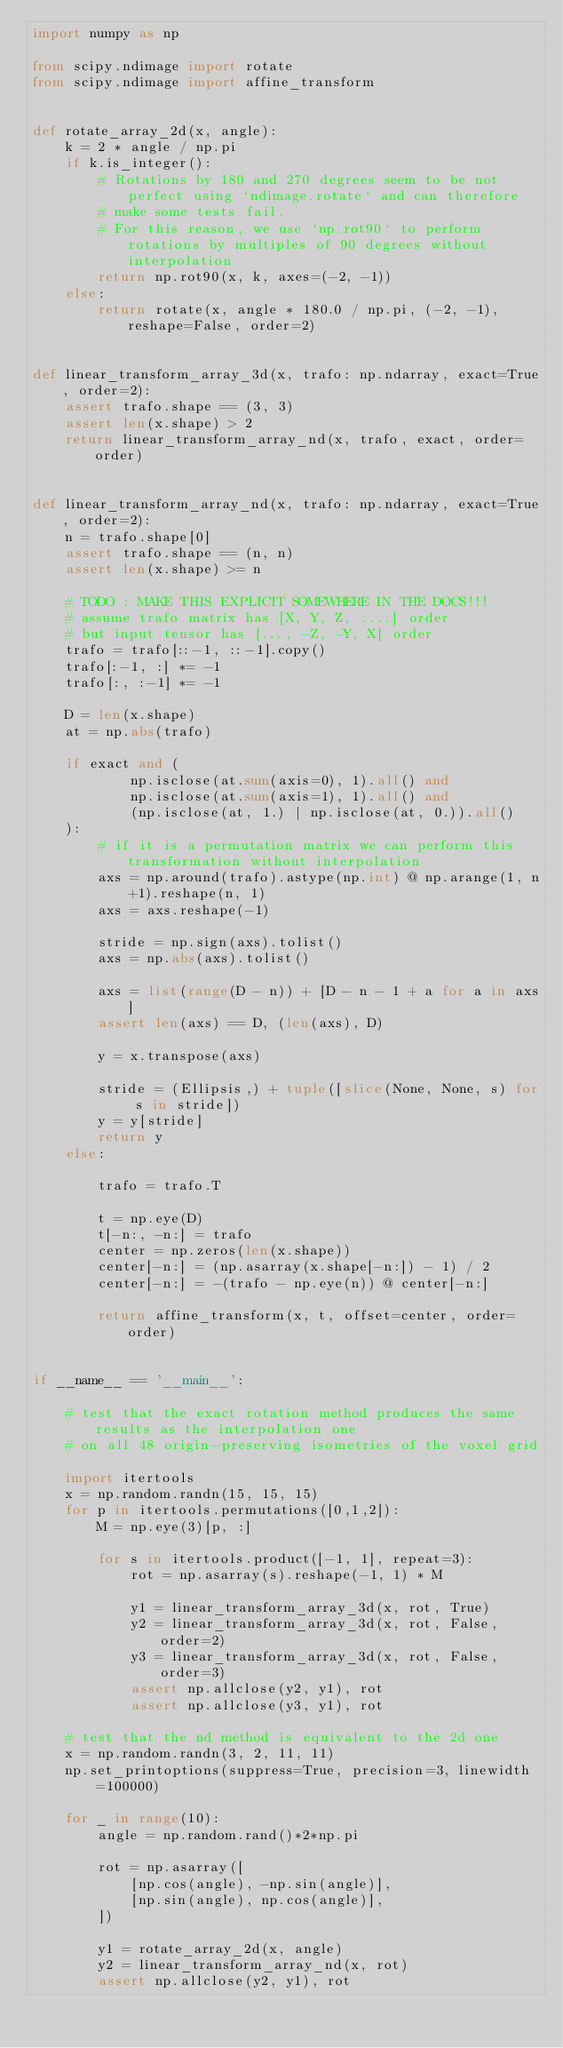<code> <loc_0><loc_0><loc_500><loc_500><_Python_>import numpy as np

from scipy.ndimage import rotate
from scipy.ndimage import affine_transform


def rotate_array_2d(x, angle):
    k = 2 * angle / np.pi
    if k.is_integer():
        # Rotations by 180 and 270 degrees seem to be not perfect using `ndimage.rotate` and can therefore
        # make some tests fail.
        # For this reason, we use `np.rot90` to perform rotations by multiples of 90 degrees without interpolation
        return np.rot90(x, k, axes=(-2, -1))
    else:
        return rotate(x, angle * 180.0 / np.pi, (-2, -1), reshape=False, order=2)


def linear_transform_array_3d(x, trafo: np.ndarray, exact=True, order=2):
    assert trafo.shape == (3, 3)
    assert len(x.shape) > 2
    return linear_transform_array_nd(x, trafo, exact, order=order)
    

def linear_transform_array_nd(x, trafo: np.ndarray, exact=True, order=2):
    n = trafo.shape[0]
    assert trafo.shape == (n, n)
    assert len(x.shape) >= n

    # TODO : MAKE THIS EXPLICIT SOMEWHERE IN THE DOCS!!!
    # assume trafo matrix has [X, Y, Z, ....] order
    # but input tensor has [..., -Z, -Y, X] order
    trafo = trafo[::-1, ::-1].copy()
    trafo[:-1, :] *= -1
    trafo[:, :-1] *= -1
    
    D = len(x.shape)
    at = np.abs(trafo)
    
    if exact and (
            np.isclose(at.sum(axis=0), 1).all() and
            np.isclose(at.sum(axis=1), 1).all() and
            (np.isclose(at, 1.) | np.isclose(at, 0.)).all()
    ):
        # if it is a permutation matrix we can perform this transformation without interpolation
        axs = np.around(trafo).astype(np.int) @ np.arange(1, n+1).reshape(n, 1)
        axs = axs.reshape(-1)
        
        stride = np.sign(axs).tolist()
        axs = np.abs(axs).tolist()
        
        axs = list(range(D - n)) + [D - n - 1 + a for a in axs]
        assert len(axs) == D, (len(axs), D)

        y = x.transpose(axs)
        
        stride = (Ellipsis,) + tuple([slice(None, None, s) for s in stride])
        y = y[stride]
        return y
    else:
        
        trafo = trafo.T

        t = np.eye(D)
        t[-n:, -n:] = trafo
        center = np.zeros(len(x.shape))
        center[-n:] = (np.asarray(x.shape[-n:]) - 1) / 2
        center[-n:] = -(trafo - np.eye(n)) @ center[-n:]

        return affine_transform(x, t, offset=center, order=order)


if __name__ == '__main__':

    # test that the exact rotation method produces the same results as the interpolation one
    # on all 48 origin-preserving isometries of the voxel grid
    
    import itertools
    x = np.random.randn(15, 15, 15)
    for p in itertools.permutations([0,1,2]):
        M = np.eye(3)[p, :]
        
        for s in itertools.product([-1, 1], repeat=3):
            rot = np.asarray(s).reshape(-1, 1) * M
            
            y1 = linear_transform_array_3d(x, rot, True)
            y2 = linear_transform_array_3d(x, rot, False, order=2)
            y3 = linear_transform_array_3d(x, rot, False, order=3)
            assert np.allclose(y2, y1), rot
            assert np.allclose(y3, y1), rot
            
    # test that the nd method is equivalent to the 2d one
    x = np.random.randn(3, 2, 11, 11)
    np.set_printoptions(suppress=True, precision=3, linewidth=100000)

    for _ in range(10):
        angle = np.random.rand()*2*np.pi
        
        rot = np.asarray([
            [np.cos(angle), -np.sin(angle)],
            [np.sin(angle), np.cos(angle)],
        ])
    
        y1 = rotate_array_2d(x, angle)
        y2 = linear_transform_array_nd(x, rot)
        assert np.allclose(y2, y1), rot
</code> 